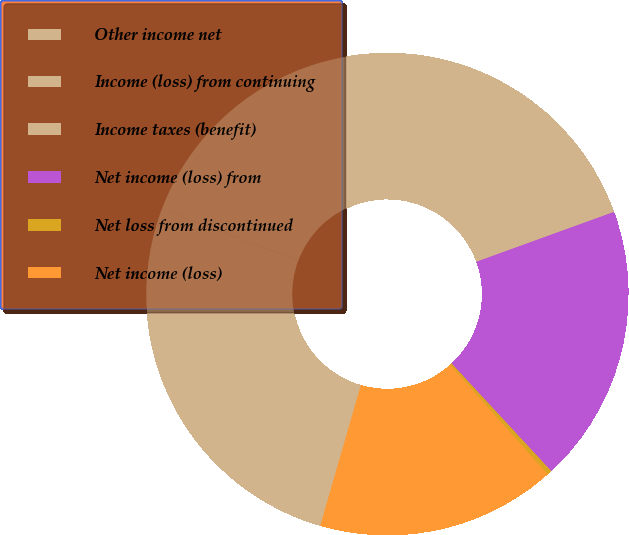<chart> <loc_0><loc_0><loc_500><loc_500><pie_chart><fcel>Other income net<fcel>Income (loss) from continuing<fcel>Income taxes (benefit)<fcel>Net income (loss) from<fcel>Net loss from discontinued<fcel>Net income (loss)<nl><fcel>26.26%<fcel>28.85%<fcel>9.88%<fcel>18.64%<fcel>0.32%<fcel>16.05%<nl></chart> 